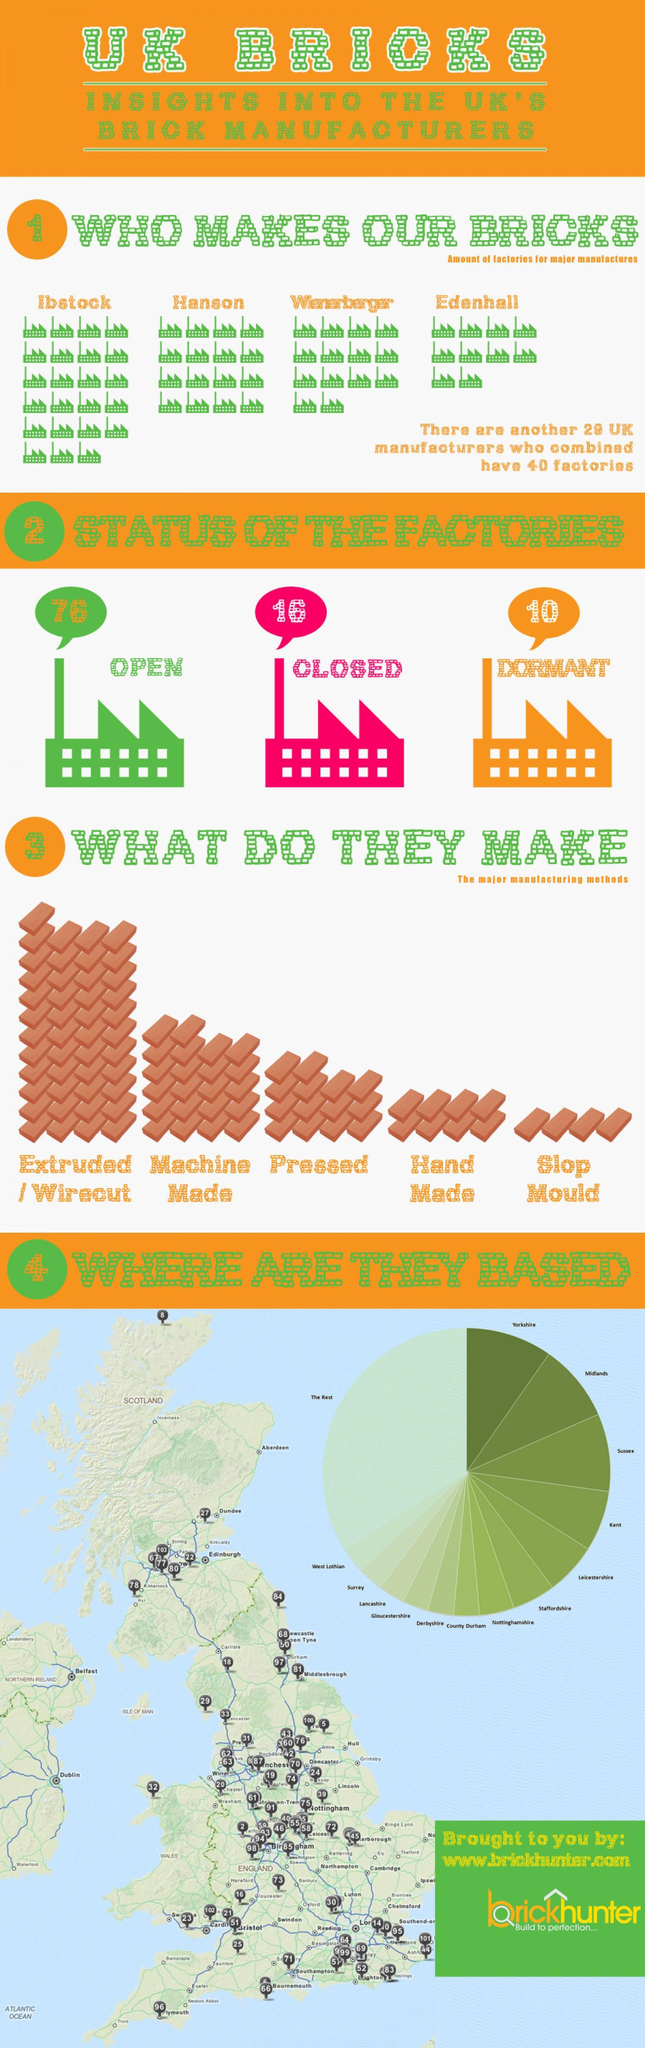What type of bricks are made in highest quantity ?
Answer the question with a short phrase. Extruded/Wirecut What is the total of closed and open factories in UK ? 92 How many factories does Wienerberger have more than Hanson ? 2 Which brick manufacturing company has a largest number of factories ? Ibstock How many types of bricks are manufactured ? 5 How many factories are dormant ? 10 In which state are majority of the manufacturers based ? Yorkshire Which is the least manufactured brick type ? Slop mould 